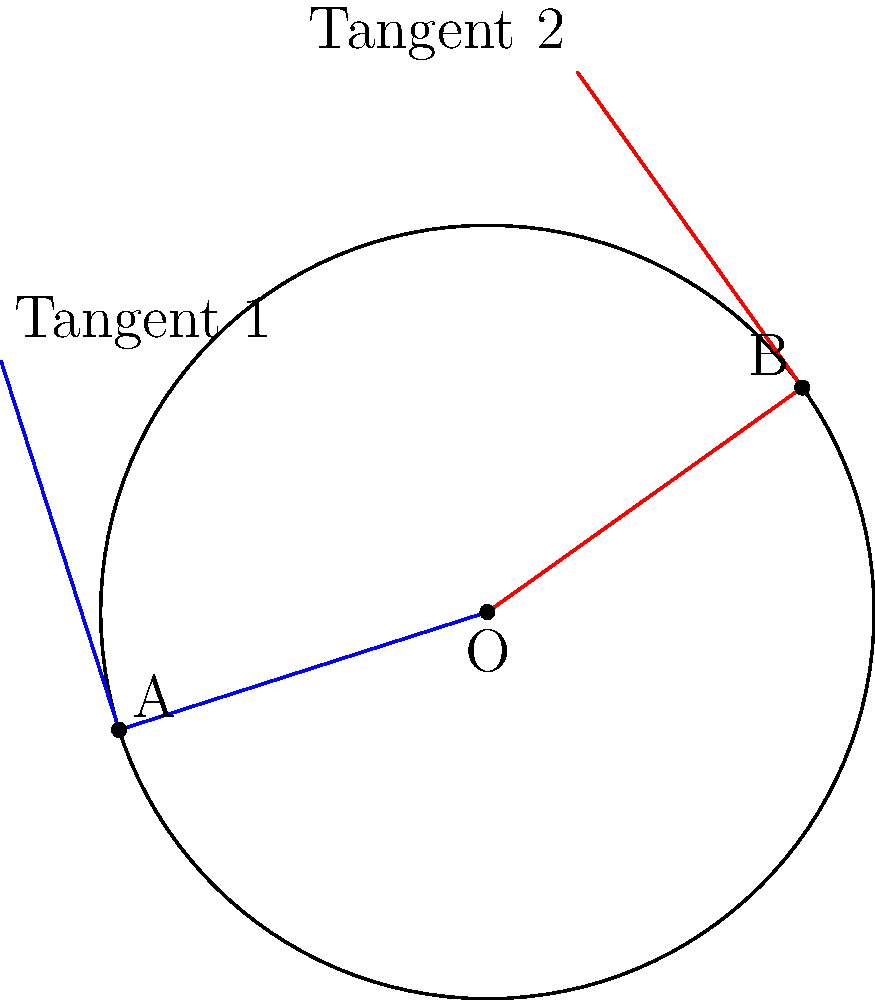In character animation, tangent lines to a circle are often used to create smooth movements. Consider a circular path with center O and radius 2 units. Two points A and B are located on the circle, forming an arc of 60°. If tangent lines are drawn at these points, what is the angle between these tangent lines? Let's approach this step-by-step:

1) First, recall that a tangent line is always perpendicular to the radius at the point of tangency. This means that the angle between the radius and the tangent is 90°.

2) The angle between two radii that form a 60° arc is also 60° (central angle theorem).

3) Let's consider the triangle formed by the two radii OA and OB:
   - The angle at O is 60°
   - The angles at A and B between the radii and tangents are both 90°

4) The sum of angles in a triangle is always 180°. So:
   $$60° + 90° + 90° = 240°$$

5) But we want the angle between the tangents, not the sum of all angles. To find this, we need to subtract 240° from 360°:
   $$360° - 240° = 120°$$

6) This makes sense geometrically: the tangent lines are "opposite" to the central angle. If the central angle is 60°, the angle between tangents should be its supplement, which is indeed 120°.

In animation, this principle is used to ensure that character movements along curved paths are smooth. The tangent lines provide the direction of movement at any point on the curve, allowing for fluid transitions and realistic motion.
Answer: 120° 